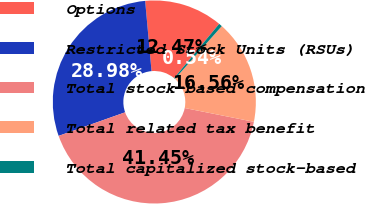Convert chart. <chart><loc_0><loc_0><loc_500><loc_500><pie_chart><fcel>Options<fcel>Restricted Stock Units (RSUs)<fcel>Total stock-based compensation<fcel>Total related tax benefit<fcel>Total capitalized stock-based<nl><fcel>12.47%<fcel>28.98%<fcel>41.45%<fcel>16.56%<fcel>0.54%<nl></chart> 